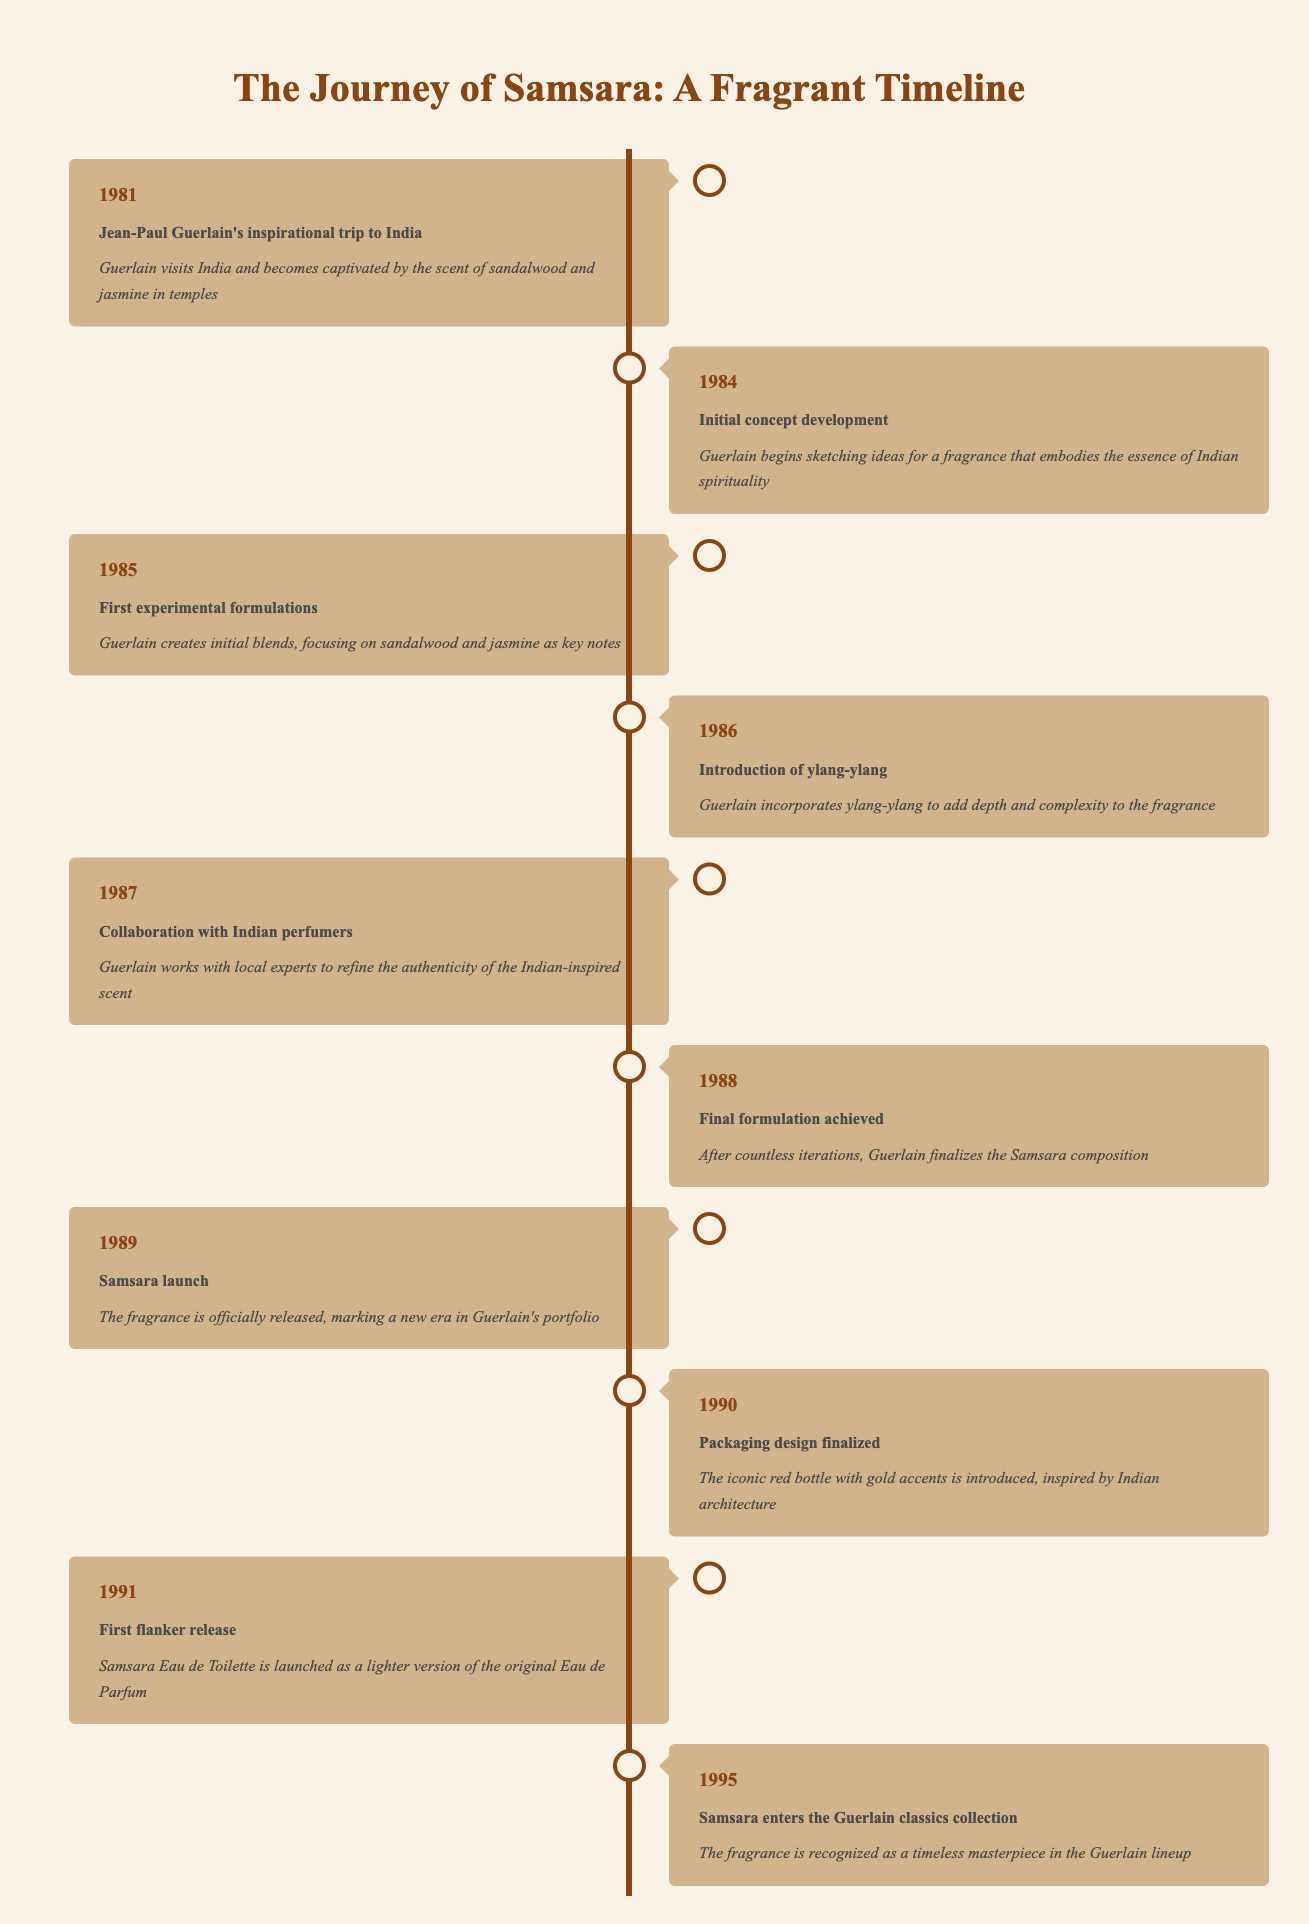What year did Jean-Paul Guerlain visit India? According to the timeline, the year Jean-Paul Guerlain went on his inspirational trip to India is listed as 1981. This is the first event in the timeline.
Answer: 1981 What was the main focus of Guerlain's first experimental formulations in 1985? The entry for 1985 states that Guerlain created initial blends, with a focus on sandalwood and jasmine as key notes. These two ingredients are critical to the composition of Samsara.
Answer: Sandalwood and jasmine When was the final formulation of Samsara achieved? The timeline indicates that the final formulation for the Samsara fragrance was achieved in 1988. This is clearly marked as a significant milestone in the development process.
Answer: 1988 How many years passed from the initial concept development to the launch of Samsara? Initial concept development occurred in 1984, and the launch happened in 1989. The difference in years is 1989 - 1984, which equals 5.
Answer: 5 Is it true that the first flanker release of Samsara took place in 1992? The timeline specifically mentions that the first flanker release occurred in 1991. Since this contradicts the stated year of 1992, the answer is false.
Answer: No What significant addition was made to the fragrance in 1986? The event from 1986 indicates that ylang-ylang was incorporated into the fragrance's composition to enhance depth and complexity.
Answer: Ylang-ylang What event marked the beginning of Guerlain’s journey into capturing Indian spirituality in fragrance? The very first event mentioned in the timeline in 1981 describes Guerlain's trip to India and his fascination with the scents there, serving as the inspiration for capturing Indian spirituality in fragrance.
Answer: His trip to India Which event indicates the introduction of the iconic packaging design? The timeline specifies that the packaging design was finalized in 1990, highlighting the introduction of the red bottle with gold accents, which was inspired by Indian architecture.
Answer: 1990 How many years after initial conceptual development was Samsara recognized as a timeless masterpiece? Initial concept development was in 1984 and Samsara was recognized as a classic in 1995. Calculating the difference gives 1995 - 1984, which is 11 years.
Answer: 11 